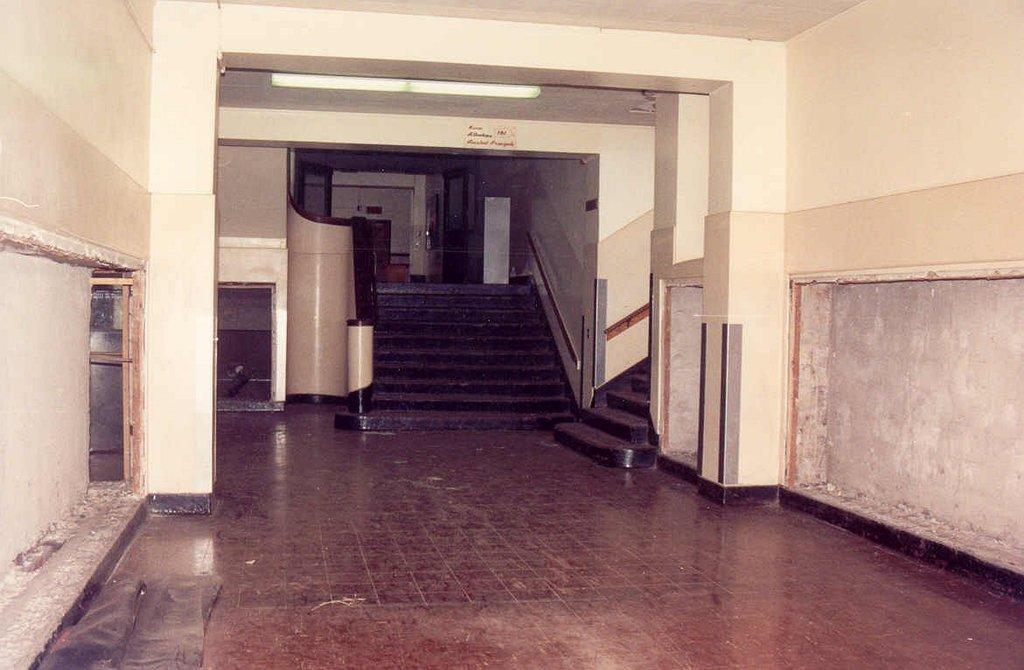Could you give a brief overview of what you see in this image? This picture is inside view of a room. In the center of the image we can see stairs are present. At the top of the image we can see light and roof are there. On the left side of the image door is present. On the right side of the image wall is there. At the bottom of the image floor is present. 